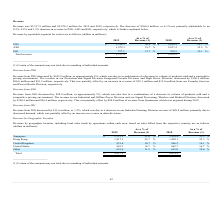From On Semiconductor's financial document, How much was Revenue for 2019 and 2018 respectively? The document shows two values: $5,517.9 million and $5,878.3 million. From the document: "Revenue was $5,517.9 million and $5,878.3 million for 2019 and 2018, respectively. The decrease of $360.4 million, or 6.1% w as primarily attributable..." Also, What led to the decrease in overall Revenue between 2018 and 2019? primarily attributable to an 8.2%, 4.8% and 1.5% decrease in revenue in PSG, ASG and ISG, respectively. The document states: "ely. The decrease of $360.4 million, or 6.1% w as primarily attributable to an 8.2%, 4.8% and 1.5% decrease in revenue in PSG, ASG and ISG, respective..." Also, What led to the decrease in Revenue from PSG? due to a combination of a decrease in volume of products sold and a competitive pricing environment.. The document states: "by $249.9 million, or approximately 8%, which was due to a combination of a decrease in volume of products sold and a competitive pricing environment...." Also, can you calculate: What is the change in revenue from PSG from 2018 to 2019? Based on the calculation: 2,788.3-3,038.2, the result is -249.9 (in millions). This is based on the information: "PSG $ 2,788.3 50.5 % $ 3,038.2 51.7 % PSG $ 2,788.3 50.5 % $ 3,038.2 51.7 %..." The key data points involved are: 2,788.3, 3,038.2. Also, can you calculate: What is the change in revenues from ASG from 2018 to 2019? Based on the calculation: 1,972.3-2,071.2, the result is -98.9 (in millions). This is based on the information: "ASG 1,972.3 35.7 % 2,071.2 35.2 % ASG 1,972.3 35.7 % 2,071.2 35.2 %..." The key data points involved are: 1,972.3, 2,071.2. Also, can you calculate: What is the average revenue from PSG for 2018 to 2019? To answer this question, I need to perform calculations using the financial data. The calculation is: (2,788.3+3,038.2) / 2, which equals 2913.25 (in millions). This is based on the information: "PSG $ 2,788.3 50.5 % $ 3,038.2 51.7 % PSG $ 2,788.3 50.5 % $ 3,038.2 51.7 %..." The key data points involved are: 2,788.3, 3,038.2. 